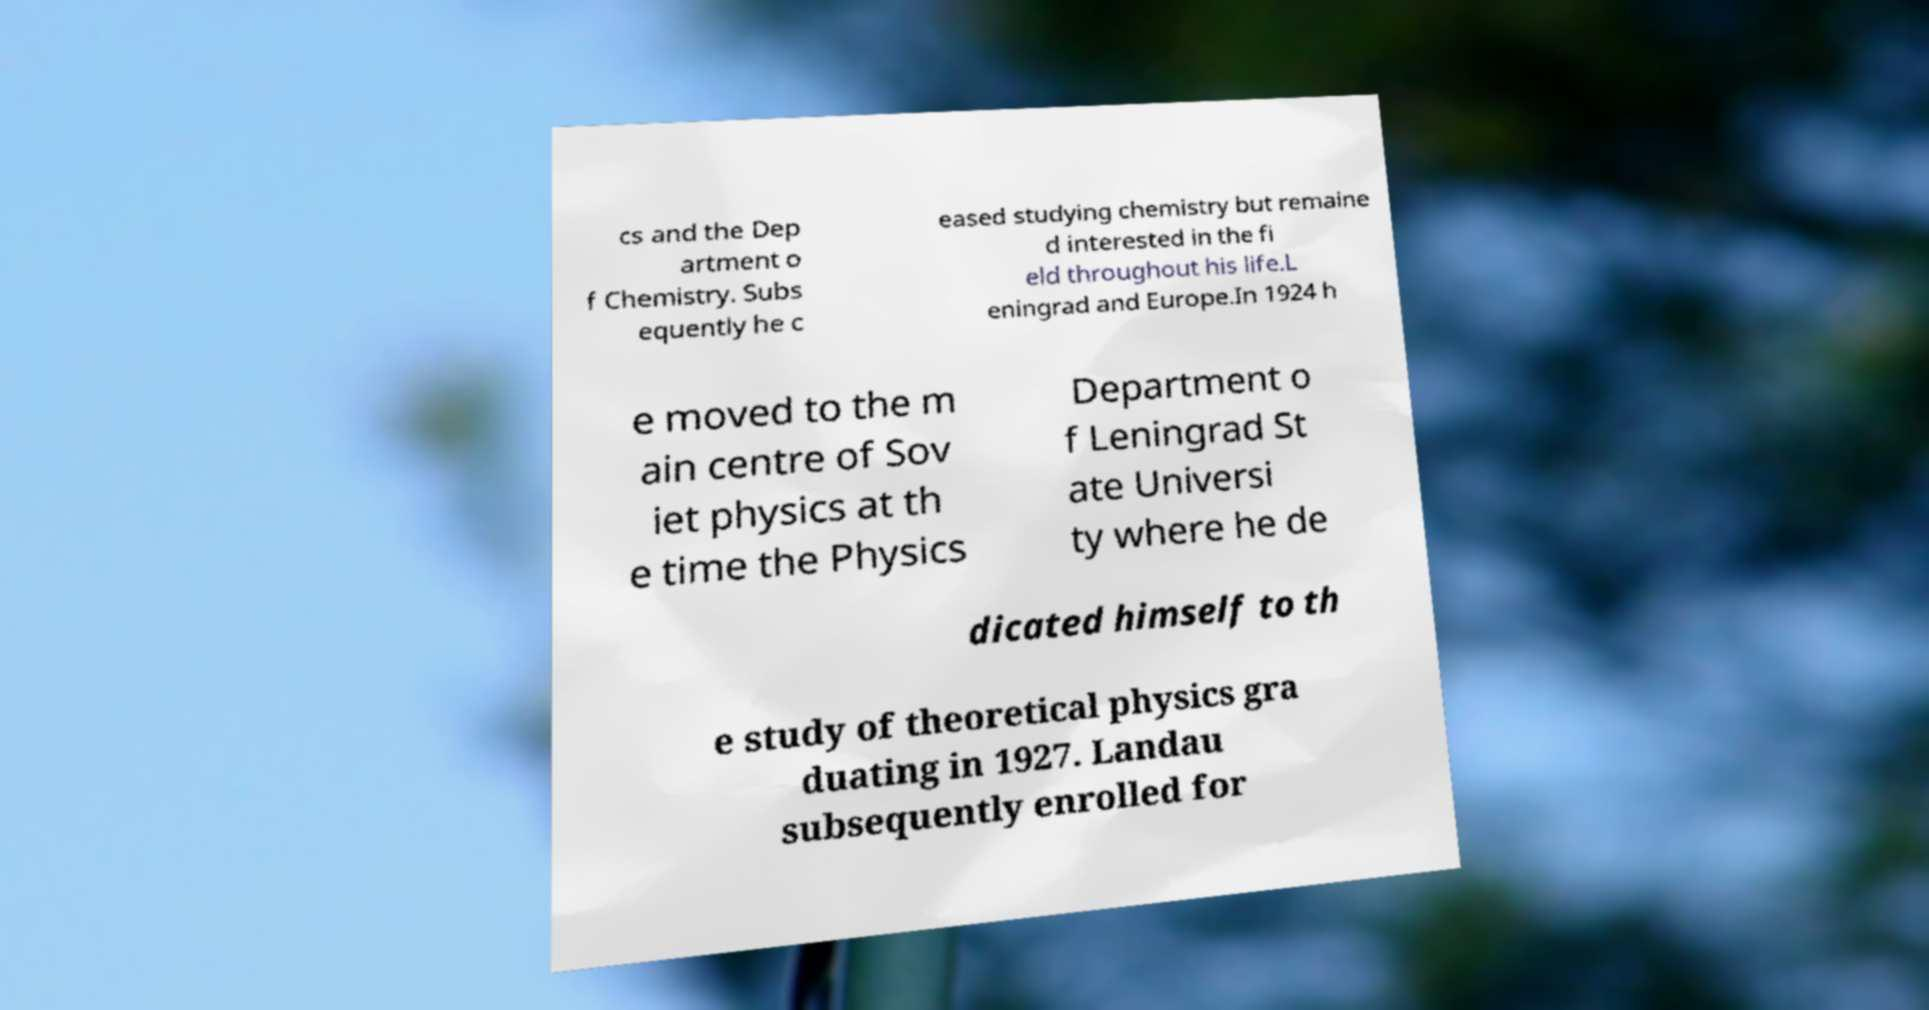Please read and relay the text visible in this image. What does it say? cs and the Dep artment o f Chemistry. Subs equently he c eased studying chemistry but remaine d interested in the fi eld throughout his life.L eningrad and Europe.In 1924 h e moved to the m ain centre of Sov iet physics at th e time the Physics Department o f Leningrad St ate Universi ty where he de dicated himself to th e study of theoretical physics gra duating in 1927. Landau subsequently enrolled for 